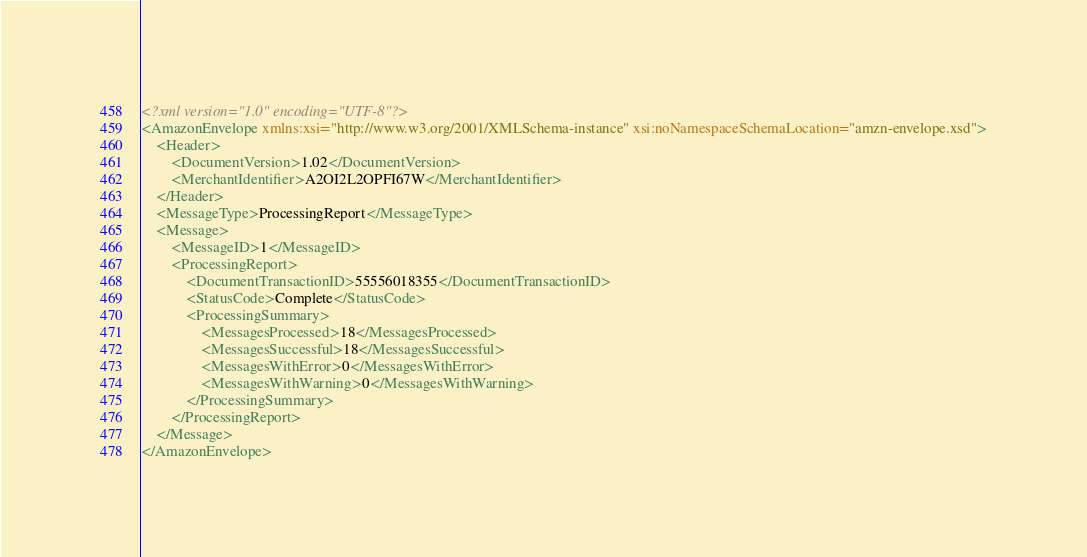Convert code to text. <code><loc_0><loc_0><loc_500><loc_500><_XML_><?xml version="1.0" encoding="UTF-8"?>
<AmazonEnvelope xmlns:xsi="http://www.w3.org/2001/XMLSchema-instance" xsi:noNamespaceSchemaLocation="amzn-envelope.xsd">
	<Header>
		<DocumentVersion>1.02</DocumentVersion>
		<MerchantIdentifier>A2OI2L2OPFI67W</MerchantIdentifier>
	</Header>
	<MessageType>ProcessingReport</MessageType>
	<Message>
		<MessageID>1</MessageID>
		<ProcessingReport>
			<DocumentTransactionID>55556018355</DocumentTransactionID>
			<StatusCode>Complete</StatusCode>
			<ProcessingSummary>
				<MessagesProcessed>18</MessagesProcessed>
				<MessagesSuccessful>18</MessagesSuccessful>
				<MessagesWithError>0</MessagesWithError>
				<MessagesWithWarning>0</MessagesWithWarning>
			</ProcessingSummary>
		</ProcessingReport>
	</Message>
</AmazonEnvelope></code> 